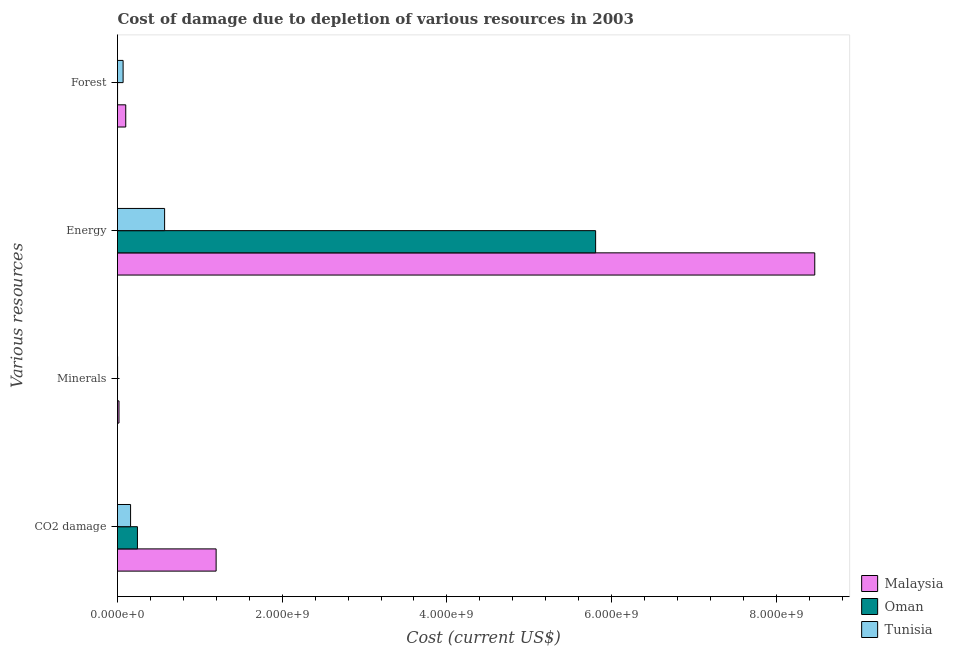Are the number of bars per tick equal to the number of legend labels?
Provide a short and direct response. Yes. How many bars are there on the 2nd tick from the bottom?
Keep it short and to the point. 3. What is the label of the 2nd group of bars from the top?
Provide a succinct answer. Energy. What is the cost of damage due to depletion of forests in Oman?
Offer a terse response. 6.05e+05. Across all countries, what is the maximum cost of damage due to depletion of coal?
Provide a short and direct response. 1.20e+09. Across all countries, what is the minimum cost of damage due to depletion of forests?
Your response must be concise. 6.05e+05. In which country was the cost of damage due to depletion of energy maximum?
Give a very brief answer. Malaysia. In which country was the cost of damage due to depletion of energy minimum?
Provide a short and direct response. Tunisia. What is the total cost of damage due to depletion of energy in the graph?
Provide a short and direct response. 1.48e+1. What is the difference between the cost of damage due to depletion of energy in Malaysia and that in Tunisia?
Ensure brevity in your answer.  7.89e+09. What is the difference between the cost of damage due to depletion of energy in Malaysia and the cost of damage due to depletion of minerals in Oman?
Offer a terse response. 8.47e+09. What is the average cost of damage due to depletion of forests per country?
Offer a terse response. 5.63e+07. What is the difference between the cost of damage due to depletion of coal and cost of damage due to depletion of energy in Tunisia?
Provide a short and direct response. -4.13e+08. In how many countries, is the cost of damage due to depletion of coal greater than 7600000000 US$?
Your response must be concise. 0. What is the ratio of the cost of damage due to depletion of forests in Oman to that in Tunisia?
Keep it short and to the point. 0.01. What is the difference between the highest and the second highest cost of damage due to depletion of energy?
Offer a very short reply. 2.66e+09. What is the difference between the highest and the lowest cost of damage due to depletion of forests?
Your answer should be compact. 9.96e+07. What does the 3rd bar from the top in Minerals represents?
Your answer should be compact. Malaysia. What does the 3rd bar from the bottom in Minerals represents?
Give a very brief answer. Tunisia. How many bars are there?
Make the answer very short. 12. Are all the bars in the graph horizontal?
Your answer should be very brief. Yes. How many countries are there in the graph?
Ensure brevity in your answer.  3. Does the graph contain grids?
Your response must be concise. No. Where does the legend appear in the graph?
Provide a short and direct response. Bottom right. How are the legend labels stacked?
Your answer should be compact. Vertical. What is the title of the graph?
Ensure brevity in your answer.  Cost of damage due to depletion of various resources in 2003 . What is the label or title of the X-axis?
Your response must be concise. Cost (current US$). What is the label or title of the Y-axis?
Your answer should be very brief. Various resources. What is the Cost (current US$) in Malaysia in CO2 damage?
Keep it short and to the point. 1.20e+09. What is the Cost (current US$) of Oman in CO2 damage?
Make the answer very short. 2.42e+08. What is the Cost (current US$) in Tunisia in CO2 damage?
Offer a very short reply. 1.59e+08. What is the Cost (current US$) of Malaysia in Minerals?
Your answer should be compact. 1.81e+07. What is the Cost (current US$) of Oman in Minerals?
Keep it short and to the point. 1.96e+05. What is the Cost (current US$) of Tunisia in Minerals?
Provide a succinct answer. 1.13e+06. What is the Cost (current US$) of Malaysia in Energy?
Your answer should be very brief. 8.47e+09. What is the Cost (current US$) of Oman in Energy?
Keep it short and to the point. 5.81e+09. What is the Cost (current US$) of Tunisia in Energy?
Your response must be concise. 5.72e+08. What is the Cost (current US$) of Malaysia in Forest?
Make the answer very short. 1.00e+08. What is the Cost (current US$) in Oman in Forest?
Provide a short and direct response. 6.05e+05. What is the Cost (current US$) in Tunisia in Forest?
Provide a short and direct response. 6.80e+07. Across all Various resources, what is the maximum Cost (current US$) of Malaysia?
Your response must be concise. 8.47e+09. Across all Various resources, what is the maximum Cost (current US$) in Oman?
Ensure brevity in your answer.  5.81e+09. Across all Various resources, what is the maximum Cost (current US$) of Tunisia?
Your answer should be very brief. 5.72e+08. Across all Various resources, what is the minimum Cost (current US$) of Malaysia?
Provide a short and direct response. 1.81e+07. Across all Various resources, what is the minimum Cost (current US$) of Oman?
Give a very brief answer. 1.96e+05. Across all Various resources, what is the minimum Cost (current US$) in Tunisia?
Your response must be concise. 1.13e+06. What is the total Cost (current US$) of Malaysia in the graph?
Provide a short and direct response. 9.78e+09. What is the total Cost (current US$) of Oman in the graph?
Your response must be concise. 6.05e+09. What is the total Cost (current US$) of Tunisia in the graph?
Offer a terse response. 8.00e+08. What is the difference between the Cost (current US$) of Malaysia in CO2 damage and that in Minerals?
Ensure brevity in your answer.  1.18e+09. What is the difference between the Cost (current US$) of Oman in CO2 damage and that in Minerals?
Offer a terse response. 2.42e+08. What is the difference between the Cost (current US$) of Tunisia in CO2 damage and that in Minerals?
Make the answer very short. 1.58e+08. What is the difference between the Cost (current US$) of Malaysia in CO2 damage and that in Energy?
Keep it short and to the point. -7.27e+09. What is the difference between the Cost (current US$) in Oman in CO2 damage and that in Energy?
Offer a terse response. -5.56e+09. What is the difference between the Cost (current US$) in Tunisia in CO2 damage and that in Energy?
Make the answer very short. -4.13e+08. What is the difference between the Cost (current US$) in Malaysia in CO2 damage and that in Forest?
Make the answer very short. 1.10e+09. What is the difference between the Cost (current US$) of Oman in CO2 damage and that in Forest?
Make the answer very short. 2.41e+08. What is the difference between the Cost (current US$) in Tunisia in CO2 damage and that in Forest?
Give a very brief answer. 9.07e+07. What is the difference between the Cost (current US$) of Malaysia in Minerals and that in Energy?
Your response must be concise. -8.45e+09. What is the difference between the Cost (current US$) of Oman in Minerals and that in Energy?
Your response must be concise. -5.81e+09. What is the difference between the Cost (current US$) of Tunisia in Minerals and that in Energy?
Offer a terse response. -5.71e+08. What is the difference between the Cost (current US$) in Malaysia in Minerals and that in Forest?
Offer a very short reply. -8.21e+07. What is the difference between the Cost (current US$) in Oman in Minerals and that in Forest?
Offer a terse response. -4.09e+05. What is the difference between the Cost (current US$) in Tunisia in Minerals and that in Forest?
Offer a terse response. -6.69e+07. What is the difference between the Cost (current US$) of Malaysia in Energy and that in Forest?
Your answer should be compact. 8.37e+09. What is the difference between the Cost (current US$) of Oman in Energy and that in Forest?
Give a very brief answer. 5.80e+09. What is the difference between the Cost (current US$) of Tunisia in Energy and that in Forest?
Provide a succinct answer. 5.04e+08. What is the difference between the Cost (current US$) of Malaysia in CO2 damage and the Cost (current US$) of Oman in Minerals?
Your answer should be very brief. 1.20e+09. What is the difference between the Cost (current US$) in Malaysia in CO2 damage and the Cost (current US$) in Tunisia in Minerals?
Provide a short and direct response. 1.20e+09. What is the difference between the Cost (current US$) in Oman in CO2 damage and the Cost (current US$) in Tunisia in Minerals?
Make the answer very short. 2.41e+08. What is the difference between the Cost (current US$) of Malaysia in CO2 damage and the Cost (current US$) of Oman in Energy?
Offer a very short reply. -4.61e+09. What is the difference between the Cost (current US$) in Malaysia in CO2 damage and the Cost (current US$) in Tunisia in Energy?
Make the answer very short. 6.25e+08. What is the difference between the Cost (current US$) in Oman in CO2 damage and the Cost (current US$) in Tunisia in Energy?
Make the answer very short. -3.30e+08. What is the difference between the Cost (current US$) in Malaysia in CO2 damage and the Cost (current US$) in Oman in Forest?
Keep it short and to the point. 1.20e+09. What is the difference between the Cost (current US$) of Malaysia in CO2 damage and the Cost (current US$) of Tunisia in Forest?
Your answer should be compact. 1.13e+09. What is the difference between the Cost (current US$) of Oman in CO2 damage and the Cost (current US$) of Tunisia in Forest?
Your answer should be compact. 1.74e+08. What is the difference between the Cost (current US$) in Malaysia in Minerals and the Cost (current US$) in Oman in Energy?
Provide a short and direct response. -5.79e+09. What is the difference between the Cost (current US$) of Malaysia in Minerals and the Cost (current US$) of Tunisia in Energy?
Provide a succinct answer. -5.54e+08. What is the difference between the Cost (current US$) in Oman in Minerals and the Cost (current US$) in Tunisia in Energy?
Offer a terse response. -5.72e+08. What is the difference between the Cost (current US$) of Malaysia in Minerals and the Cost (current US$) of Oman in Forest?
Your response must be concise. 1.75e+07. What is the difference between the Cost (current US$) of Malaysia in Minerals and the Cost (current US$) of Tunisia in Forest?
Ensure brevity in your answer.  -4.99e+07. What is the difference between the Cost (current US$) in Oman in Minerals and the Cost (current US$) in Tunisia in Forest?
Your answer should be very brief. -6.78e+07. What is the difference between the Cost (current US$) in Malaysia in Energy and the Cost (current US$) in Oman in Forest?
Offer a very short reply. 8.47e+09. What is the difference between the Cost (current US$) of Malaysia in Energy and the Cost (current US$) of Tunisia in Forest?
Keep it short and to the point. 8.40e+09. What is the difference between the Cost (current US$) in Oman in Energy and the Cost (current US$) in Tunisia in Forest?
Make the answer very short. 5.74e+09. What is the average Cost (current US$) in Malaysia per Various resources?
Keep it short and to the point. 2.45e+09. What is the average Cost (current US$) in Oman per Various resources?
Your answer should be compact. 1.51e+09. What is the average Cost (current US$) of Tunisia per Various resources?
Your answer should be very brief. 2.00e+08. What is the difference between the Cost (current US$) in Malaysia and Cost (current US$) in Oman in CO2 damage?
Keep it short and to the point. 9.55e+08. What is the difference between the Cost (current US$) in Malaysia and Cost (current US$) in Tunisia in CO2 damage?
Give a very brief answer. 1.04e+09. What is the difference between the Cost (current US$) of Oman and Cost (current US$) of Tunisia in CO2 damage?
Ensure brevity in your answer.  8.33e+07. What is the difference between the Cost (current US$) of Malaysia and Cost (current US$) of Oman in Minerals?
Make the answer very short. 1.79e+07. What is the difference between the Cost (current US$) of Malaysia and Cost (current US$) of Tunisia in Minerals?
Ensure brevity in your answer.  1.70e+07. What is the difference between the Cost (current US$) of Oman and Cost (current US$) of Tunisia in Minerals?
Keep it short and to the point. -9.35e+05. What is the difference between the Cost (current US$) of Malaysia and Cost (current US$) of Oman in Energy?
Your answer should be very brief. 2.66e+09. What is the difference between the Cost (current US$) in Malaysia and Cost (current US$) in Tunisia in Energy?
Provide a succinct answer. 7.89e+09. What is the difference between the Cost (current US$) in Oman and Cost (current US$) in Tunisia in Energy?
Your response must be concise. 5.23e+09. What is the difference between the Cost (current US$) in Malaysia and Cost (current US$) in Oman in Forest?
Keep it short and to the point. 9.96e+07. What is the difference between the Cost (current US$) in Malaysia and Cost (current US$) in Tunisia in Forest?
Give a very brief answer. 3.21e+07. What is the difference between the Cost (current US$) in Oman and Cost (current US$) in Tunisia in Forest?
Your answer should be very brief. -6.74e+07. What is the ratio of the Cost (current US$) of Malaysia in CO2 damage to that in Minerals?
Ensure brevity in your answer.  66.19. What is the ratio of the Cost (current US$) of Oman in CO2 damage to that in Minerals?
Offer a very short reply. 1234.51. What is the ratio of the Cost (current US$) of Tunisia in CO2 damage to that in Minerals?
Your answer should be compact. 140.38. What is the ratio of the Cost (current US$) in Malaysia in CO2 damage to that in Energy?
Give a very brief answer. 0.14. What is the ratio of the Cost (current US$) in Oman in CO2 damage to that in Energy?
Give a very brief answer. 0.04. What is the ratio of the Cost (current US$) in Tunisia in CO2 damage to that in Energy?
Provide a succinct answer. 0.28. What is the ratio of the Cost (current US$) of Malaysia in CO2 damage to that in Forest?
Offer a terse response. 11.96. What is the ratio of the Cost (current US$) of Oman in CO2 damage to that in Forest?
Your answer should be compact. 399.87. What is the ratio of the Cost (current US$) of Tunisia in CO2 damage to that in Forest?
Keep it short and to the point. 2.33. What is the ratio of the Cost (current US$) of Malaysia in Minerals to that in Energy?
Provide a short and direct response. 0. What is the ratio of the Cost (current US$) of Oman in Minerals to that in Energy?
Provide a succinct answer. 0. What is the ratio of the Cost (current US$) in Tunisia in Minerals to that in Energy?
Make the answer very short. 0. What is the ratio of the Cost (current US$) of Malaysia in Minerals to that in Forest?
Provide a succinct answer. 0.18. What is the ratio of the Cost (current US$) of Oman in Minerals to that in Forest?
Your answer should be compact. 0.32. What is the ratio of the Cost (current US$) in Tunisia in Minerals to that in Forest?
Keep it short and to the point. 0.02. What is the ratio of the Cost (current US$) in Malaysia in Energy to that in Forest?
Keep it short and to the point. 84.53. What is the ratio of the Cost (current US$) of Oman in Energy to that in Forest?
Offer a very short reply. 9592.74. What is the ratio of the Cost (current US$) in Tunisia in Energy to that in Forest?
Offer a terse response. 8.41. What is the difference between the highest and the second highest Cost (current US$) in Malaysia?
Ensure brevity in your answer.  7.27e+09. What is the difference between the highest and the second highest Cost (current US$) of Oman?
Give a very brief answer. 5.56e+09. What is the difference between the highest and the second highest Cost (current US$) in Tunisia?
Your answer should be very brief. 4.13e+08. What is the difference between the highest and the lowest Cost (current US$) of Malaysia?
Keep it short and to the point. 8.45e+09. What is the difference between the highest and the lowest Cost (current US$) in Oman?
Offer a terse response. 5.81e+09. What is the difference between the highest and the lowest Cost (current US$) in Tunisia?
Ensure brevity in your answer.  5.71e+08. 